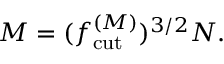<formula> <loc_0><loc_0><loc_500><loc_500>M = ( { f _ { c u t } ^ { ( M ) } } ) ^ { 3 / 2 } N .</formula> 